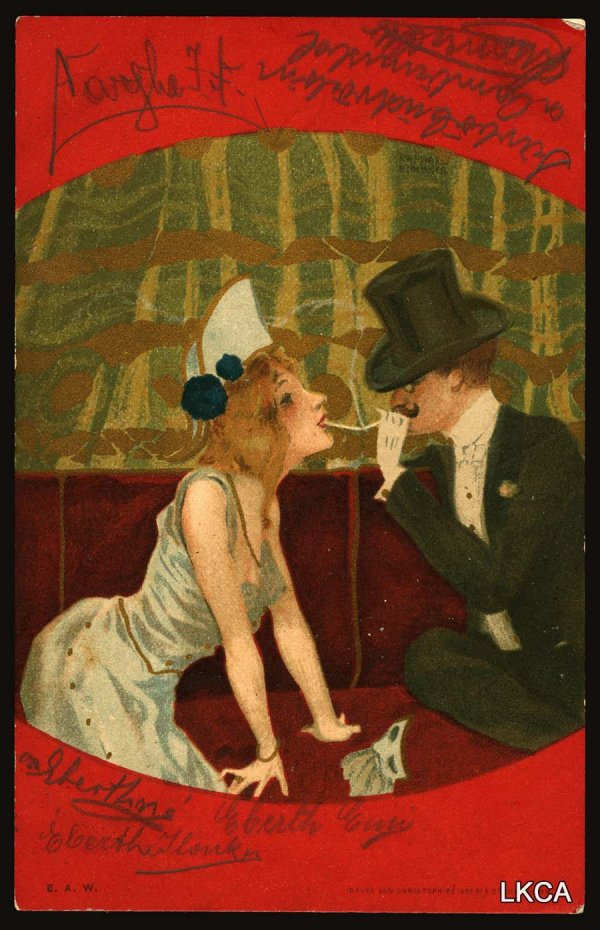Imagine a story that led up to this moment. In the bustling streets of Paris, a young man named Theo meets a charming woman named Elise at a lively café. They find themselves drawn to each other, captivated by their shared appreciation for art and music. Over a few weeks, their friendship blossoms into a deep romance. One evening, Theo invites Elise to a private gallery viewing featuring his own secret artwork. As Elise views the pieces, she discovers one particularly captivating painting—a romantic interpretation of themselves on a red couch, much like the moment captured in the image. They share a tender moment, realizing their love has transformed into something timeless and beautiful. 